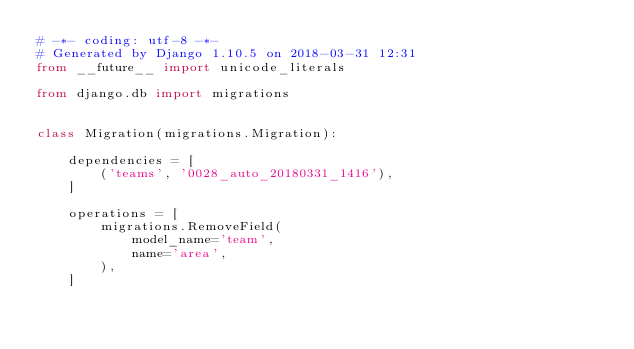<code> <loc_0><loc_0><loc_500><loc_500><_Python_># -*- coding: utf-8 -*-
# Generated by Django 1.10.5 on 2018-03-31 12:31
from __future__ import unicode_literals

from django.db import migrations


class Migration(migrations.Migration):

    dependencies = [
        ('teams', '0028_auto_20180331_1416'),
    ]

    operations = [
        migrations.RemoveField(
            model_name='team',
            name='area',
        ),
    ]
</code> 